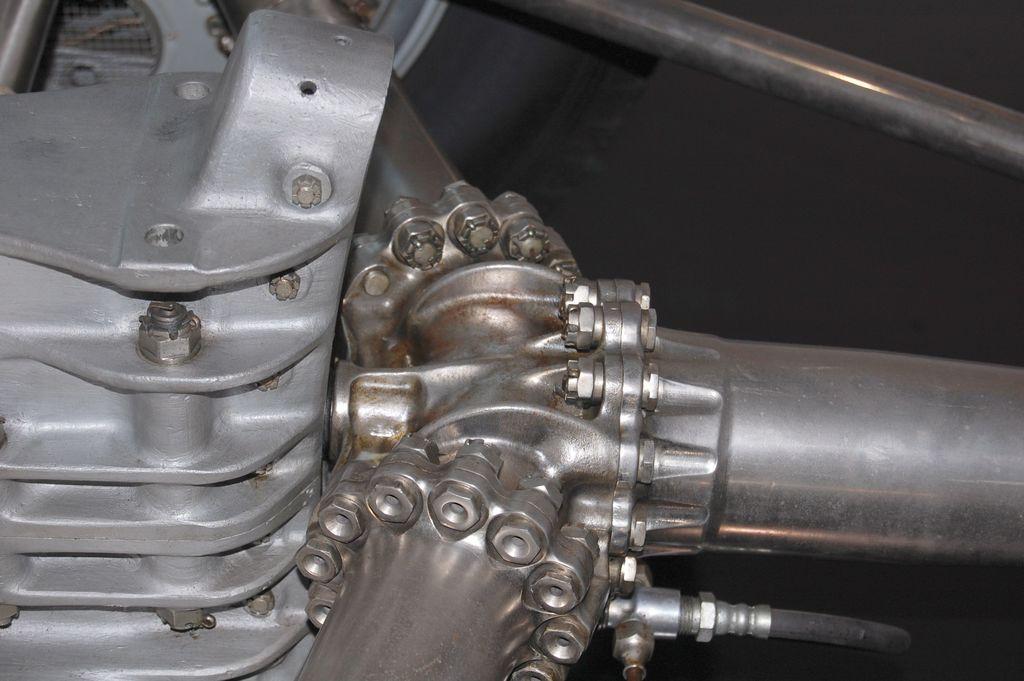Can you describe this image briefly? In this image we can see a metal object. Also there are metal pipes with nuts and bolts. And there is a pipe connected to the metal pipe. 